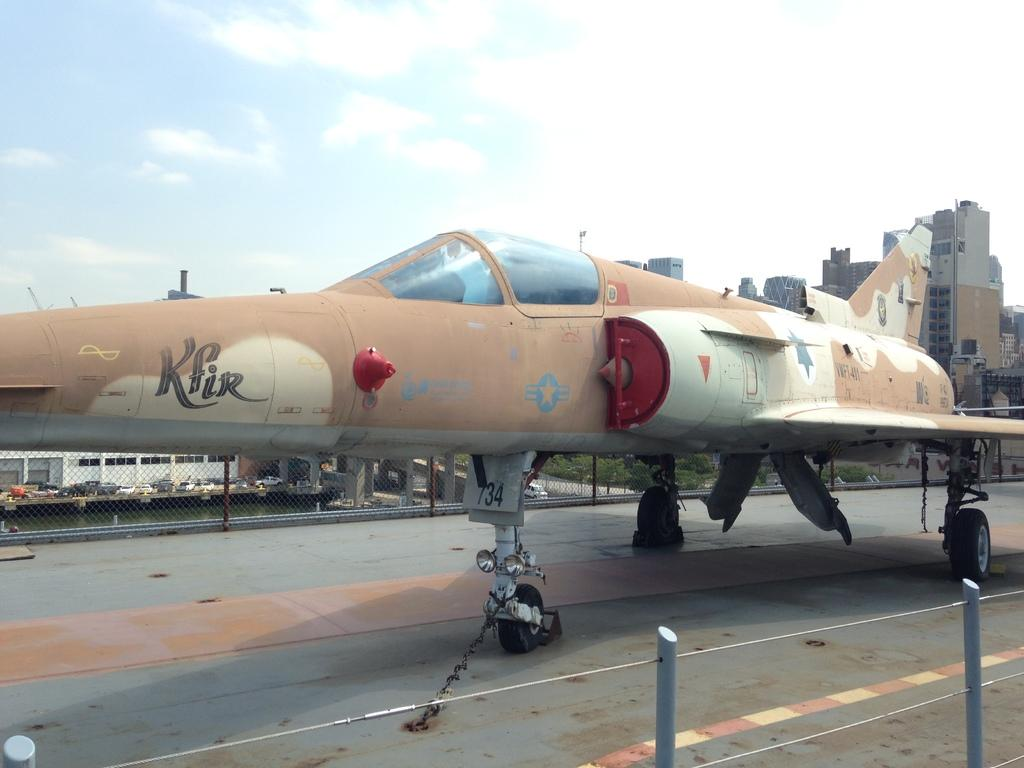<image>
Summarize the visual content of the image. Kfir appears on the side of a plane in fancy lettering. 